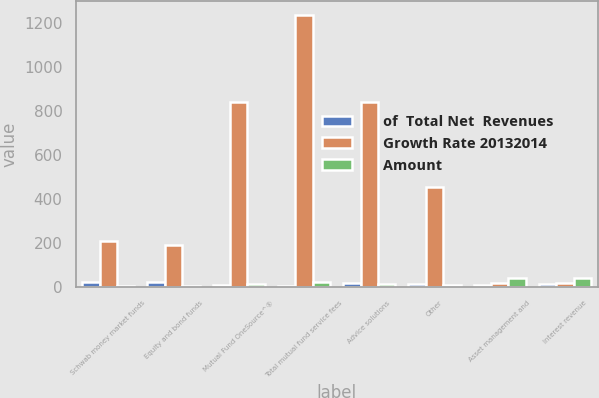<chart> <loc_0><loc_0><loc_500><loc_500><stacked_bar_chart><ecel><fcel>Schwab money market funds<fcel>Equity and bond funds<fcel>Mutual Fund OneSource^®<fcel>Total mutual fund service fees<fcel>Advice solutions<fcel>Other<fcel>Asset management and<fcel>Interest revenue<nl><fcel>of  Total Net  Revenues<fcel>21<fcel>22<fcel>8<fcel>4<fcel>17<fcel>13<fcel>9<fcel>14<nl><fcel>Growth Rate 20132014<fcel>206<fcel>192<fcel>839<fcel>1237<fcel>840<fcel>456<fcel>18.5<fcel>18.5<nl><fcel>Amount<fcel>3<fcel>3<fcel>14<fcel>20<fcel>14<fcel>8<fcel>42<fcel>39<nl></chart> 